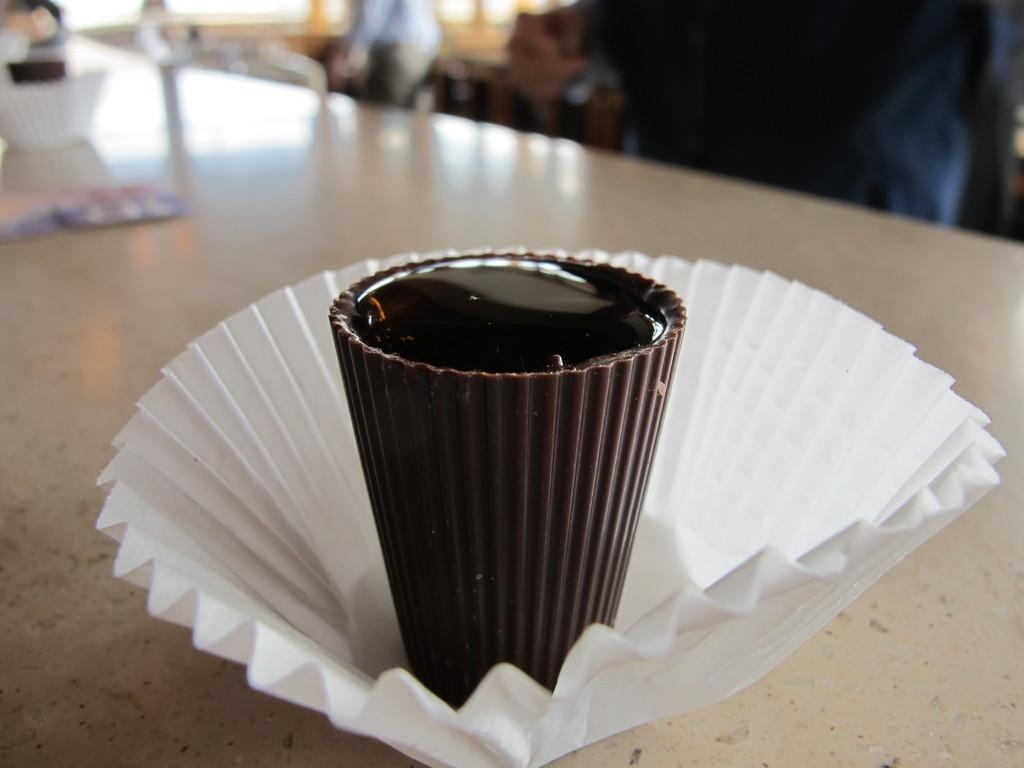What is the main object in the image? There is a chocolate in the image. What is the color of the paper in the image? The paper in the image is white. Where are the chocolate and paper located? Both the chocolate and the paper are placed on a table. How would you describe the background of the image? The background of the image is blurred. Can you see a dog interacting with the chocolate on the table in the image? There is no dog present in the image, and the chocolate is not interacting with any other object. 